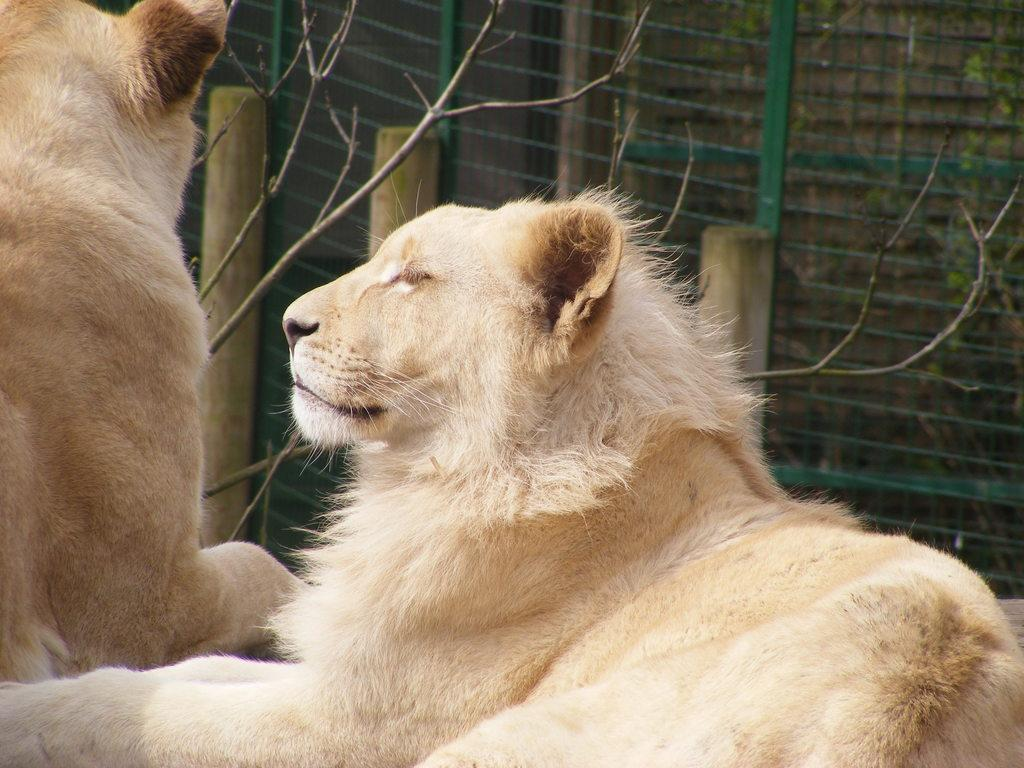What animals are present in the image? There are lions in the image. What type of vegetation can be seen in the background of the image? There is bamboo in the background of the image. What material is present in the background of the image? There is mesh in the background of the image. What else can be seen in the background of the image? There are plants in the background of the image. Who is the manager of the zoo in the image? There is no zoo present in the image, and therefore no manager can be identified. How many horses are visible in the image? There are no horses present in the image. 